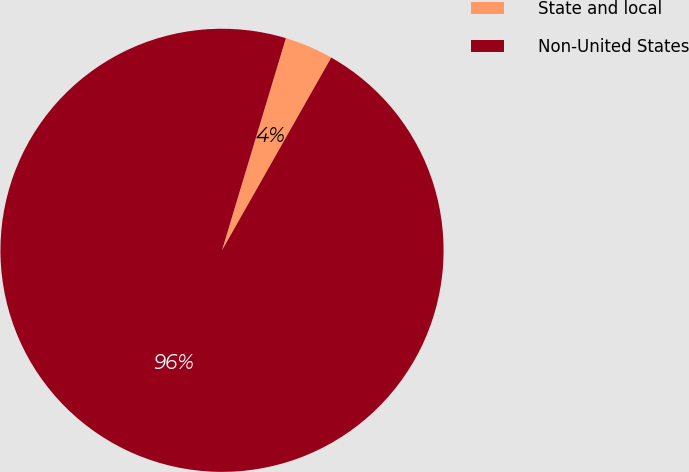Convert chart. <chart><loc_0><loc_0><loc_500><loc_500><pie_chart><fcel>State and local<fcel>Non-United States<nl><fcel>3.55%<fcel>96.45%<nl></chart> 